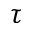Convert formula to latex. <formula><loc_0><loc_0><loc_500><loc_500>\tau</formula> 